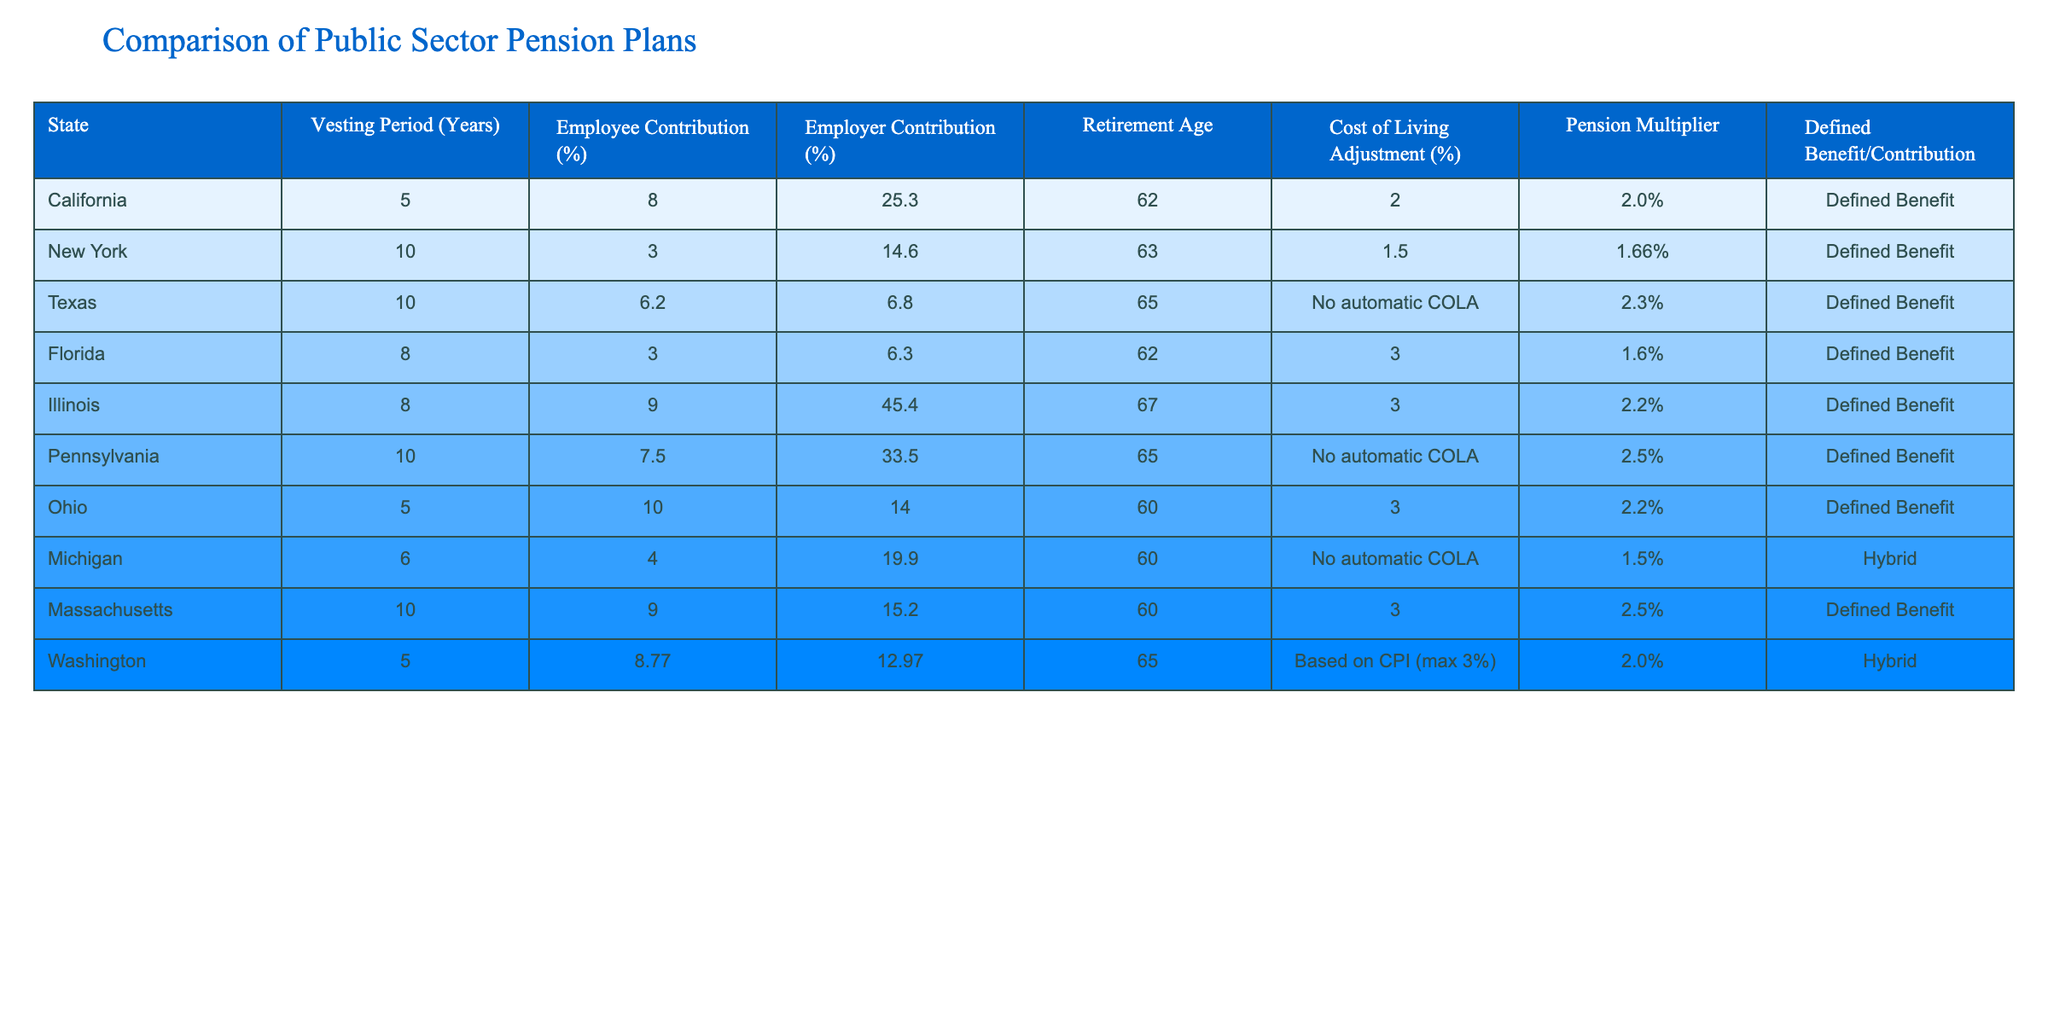What is the vesting period for California's pension plan? The table shows the vesting period for California's pension plan is listed under the "Vesting Period (Years)" column, which states 5 years.
Answer: 5 years Which state has the highest employer contribution rate? Looking through the "Employer Contribution (%)" column, Illinois is highlighted as having the highest employer contribution rate at 45.4%.
Answer: 45.4% What is the average retirement age for the states listed? The retirement ages are 62, 63, 65, 67, 65, 60, 60, 65. Adding these gives 64, and dividing by 8 states yields an average retirement age of 64.
Answer: 64 Is there a cost of living adjustment in Texas's pension plan? The table indicates that Texas has "No automatic COLA" listed under the "Cost of Living Adjustment (%)" column.
Answer: No Which state offers the lowest employee contribution percentage? By scanning the "Employee Contribution (%)" column, Florida has the lowest employee contribution rate, which is 3%.
Answer: 3% What is the difference in pension multipliers between New York and Pennsylvania? The pension multiplier for New York is 1.66% and for Pennsylvania is 2.5%. The difference is 2.5% - 1.66% = 0.84%.
Answer: 0.84% Do any states provide a hybrid pension plan? Reviewing the "Defined Benefit/Contribution" column reveals that Michigan and Washington have hybrid plans listed.
Answer: Yes Which state has both the highest employee contribution and retirement age? Illinois has the highest employee contribution at 9% and a retirement age of 67, which is higher than any other state's combination in those two categories.
Answer: Illinois What is the total percentage of contributions (employee + employer) from states that have a retirement age of 65? In Texas, the total is 6.2 + 6.8 = 13% and in Pennsylvania, it is 7.5 + 33.5 = 41%. Adding these gives 41% + 13% = 54%.
Answer: 54% How many states offer a pension multiplier of 3 or more? The table lists three states with a pension multiplier of 3 or more: Florida (3), Illinois (3), and Pennsylvania (3), totaling three states.
Answer: 3 